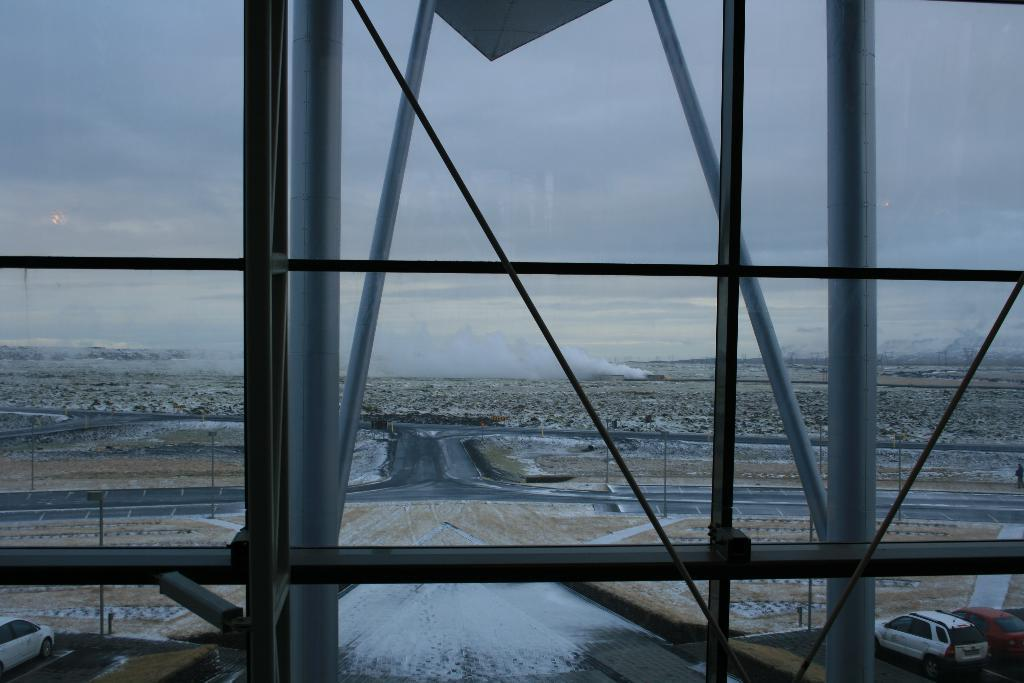What is the main feature in the middle of the image? There is a road in the middle of the image. What type of objects can be seen besides the road? Metal rods are present in the image. What can be seen in the sky in the background of the image? There are clouds in the sky in the background of the image. What type of news can be seen on the top of the metal rods in the image? There is no news present in the image, and the metal rods do not have any news on them. Can you tell me the color of the pickle on the road in the image? There is no pickle present in the image; it is a road with metal rods and clouds in the sky. 